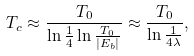<formula> <loc_0><loc_0><loc_500><loc_500>T _ { c } \approx \frac { T _ { 0 } } { \ln \frac { 1 } { 4 } \ln \frac { T _ { 0 } } { | E _ { b } | } } \approx \frac { T _ { 0 } } { \ln \frac { 1 } { 4 \lambda } } ,</formula> 